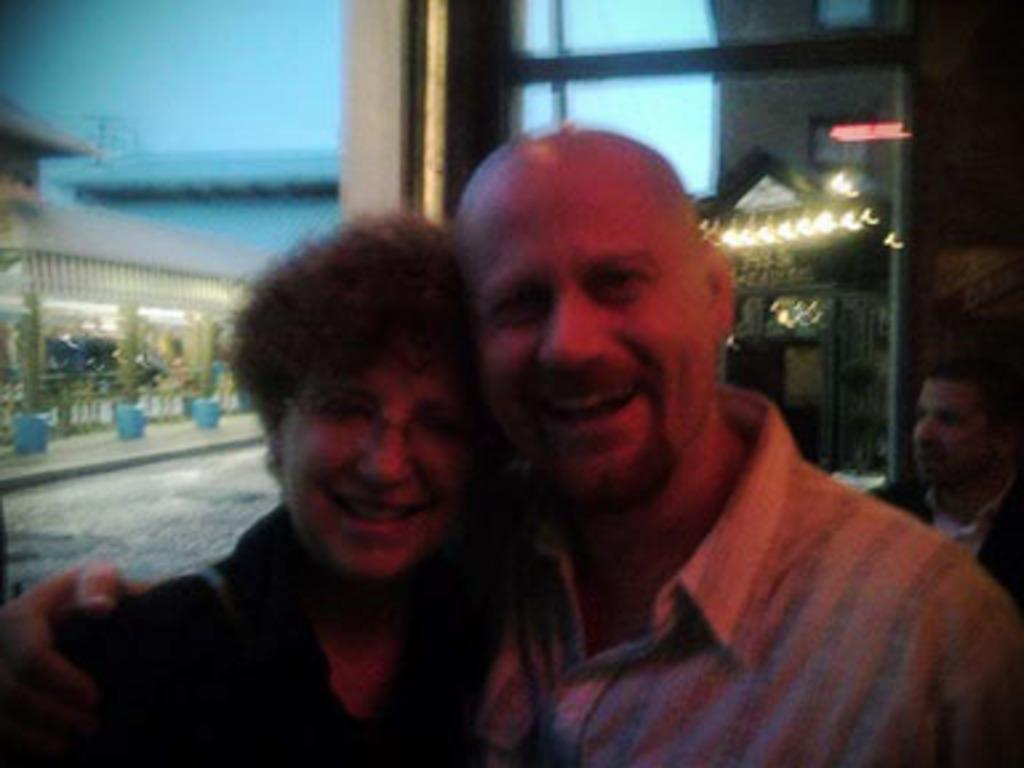How many people are present in the image? There are two people, a man and a woman, present in the image. What can be seen in the background of the image? There are lights and a building in the background of the image. Are there any other people visible in the image? Yes, there is another man in the background of the image. How would you describe the quality of the image? The image appears to be blurry. What day of the week is it in the image? The day of the week is not mentioned or visible in the image. Is there a park visible in the image? There is no park present in the image. 